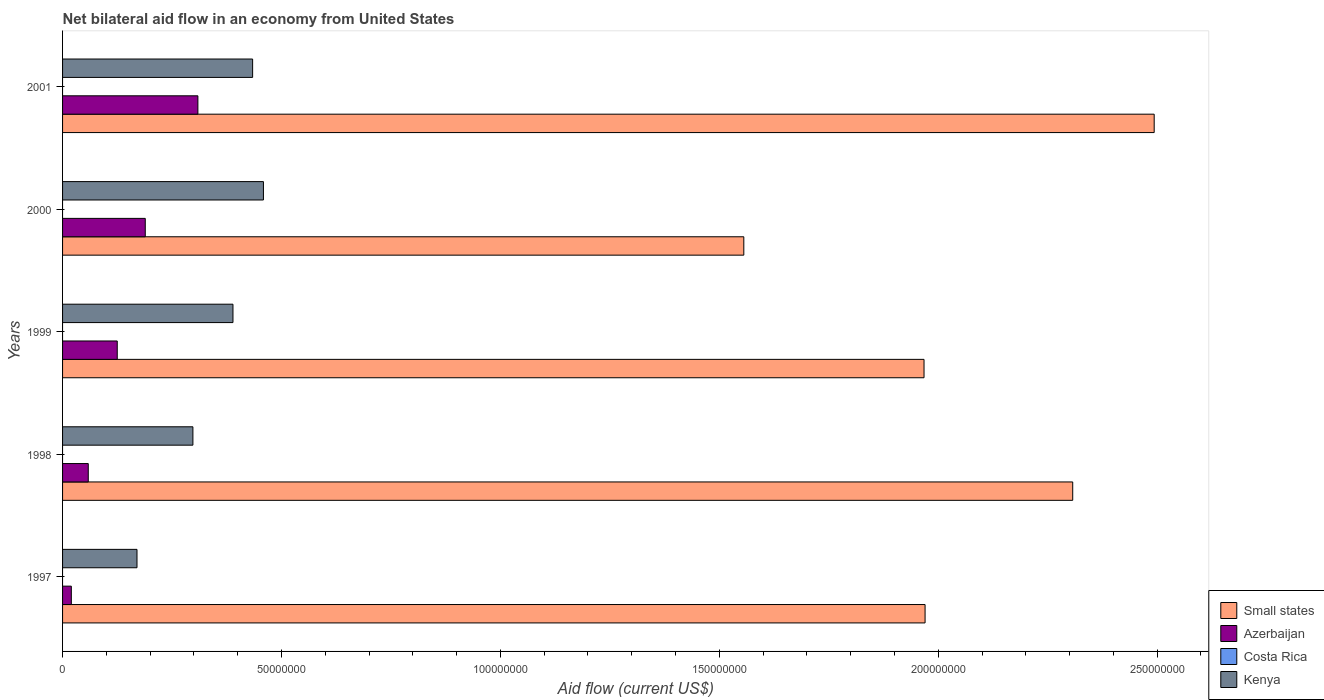How many different coloured bars are there?
Offer a terse response. 3. How many groups of bars are there?
Give a very brief answer. 5. How many bars are there on the 5th tick from the top?
Provide a succinct answer. 3. How many bars are there on the 1st tick from the bottom?
Offer a very short reply. 3. In how many cases, is the number of bars for a given year not equal to the number of legend labels?
Provide a succinct answer. 5. What is the net bilateral aid flow in Costa Rica in 1998?
Ensure brevity in your answer.  0. Across all years, what is the maximum net bilateral aid flow in Kenya?
Your answer should be very brief. 4.59e+07. Across all years, what is the minimum net bilateral aid flow in Costa Rica?
Offer a very short reply. 0. In which year was the net bilateral aid flow in Azerbaijan maximum?
Your response must be concise. 2001. What is the total net bilateral aid flow in Azerbaijan in the graph?
Provide a succinct answer. 7.02e+07. What is the difference between the net bilateral aid flow in Kenya in 2000 and that in 2001?
Provide a short and direct response. 2.47e+06. What is the difference between the net bilateral aid flow in Small states in 1997 and the net bilateral aid flow in Kenya in 2001?
Your response must be concise. 1.54e+08. What is the average net bilateral aid flow in Azerbaijan per year?
Your answer should be compact. 1.40e+07. In the year 2000, what is the difference between the net bilateral aid flow in Azerbaijan and net bilateral aid flow in Kenya?
Ensure brevity in your answer.  -2.70e+07. In how many years, is the net bilateral aid flow in Azerbaijan greater than 50000000 US$?
Your answer should be very brief. 0. What is the ratio of the net bilateral aid flow in Azerbaijan in 1997 to that in 1999?
Offer a very short reply. 0.16. Is the difference between the net bilateral aid flow in Azerbaijan in 1999 and 2001 greater than the difference between the net bilateral aid flow in Kenya in 1999 and 2001?
Provide a short and direct response. No. What is the difference between the highest and the second highest net bilateral aid flow in Azerbaijan?
Provide a short and direct response. 1.20e+07. What is the difference between the highest and the lowest net bilateral aid flow in Kenya?
Give a very brief answer. 2.89e+07. In how many years, is the net bilateral aid flow in Azerbaijan greater than the average net bilateral aid flow in Azerbaijan taken over all years?
Provide a short and direct response. 2. Is it the case that in every year, the sum of the net bilateral aid flow in Small states and net bilateral aid flow in Costa Rica is greater than the net bilateral aid flow in Azerbaijan?
Ensure brevity in your answer.  Yes. How many bars are there?
Your answer should be compact. 15. Are all the bars in the graph horizontal?
Offer a very short reply. Yes. How many years are there in the graph?
Make the answer very short. 5. What is the difference between two consecutive major ticks on the X-axis?
Provide a succinct answer. 5.00e+07. Does the graph contain grids?
Provide a short and direct response. No. How many legend labels are there?
Your answer should be compact. 4. How are the legend labels stacked?
Provide a short and direct response. Vertical. What is the title of the graph?
Provide a short and direct response. Net bilateral aid flow in an economy from United States. What is the label or title of the X-axis?
Your answer should be compact. Aid flow (current US$). What is the Aid flow (current US$) in Small states in 1997?
Make the answer very short. 1.97e+08. What is the Aid flow (current US$) of Kenya in 1997?
Your answer should be compact. 1.70e+07. What is the Aid flow (current US$) of Small states in 1998?
Provide a short and direct response. 2.31e+08. What is the Aid flow (current US$) in Azerbaijan in 1998?
Offer a terse response. 5.87e+06. What is the Aid flow (current US$) of Costa Rica in 1998?
Your response must be concise. 0. What is the Aid flow (current US$) of Kenya in 1998?
Offer a very short reply. 2.98e+07. What is the Aid flow (current US$) of Small states in 1999?
Provide a succinct answer. 1.97e+08. What is the Aid flow (current US$) of Azerbaijan in 1999?
Make the answer very short. 1.25e+07. What is the Aid flow (current US$) in Kenya in 1999?
Provide a short and direct response. 3.89e+07. What is the Aid flow (current US$) in Small states in 2000?
Your answer should be compact. 1.56e+08. What is the Aid flow (current US$) in Azerbaijan in 2000?
Give a very brief answer. 1.89e+07. What is the Aid flow (current US$) in Kenya in 2000?
Keep it short and to the point. 4.59e+07. What is the Aid flow (current US$) in Small states in 2001?
Your answer should be very brief. 2.49e+08. What is the Aid flow (current US$) of Azerbaijan in 2001?
Provide a succinct answer. 3.09e+07. What is the Aid flow (current US$) in Kenya in 2001?
Your answer should be compact. 4.34e+07. Across all years, what is the maximum Aid flow (current US$) of Small states?
Offer a very short reply. 2.49e+08. Across all years, what is the maximum Aid flow (current US$) of Azerbaijan?
Provide a succinct answer. 3.09e+07. Across all years, what is the maximum Aid flow (current US$) in Kenya?
Make the answer very short. 4.59e+07. Across all years, what is the minimum Aid flow (current US$) of Small states?
Your answer should be very brief. 1.56e+08. Across all years, what is the minimum Aid flow (current US$) in Kenya?
Your answer should be very brief. 1.70e+07. What is the total Aid flow (current US$) of Small states in the graph?
Provide a succinct answer. 1.03e+09. What is the total Aid flow (current US$) of Azerbaijan in the graph?
Your response must be concise. 7.02e+07. What is the total Aid flow (current US$) in Costa Rica in the graph?
Provide a succinct answer. 0. What is the total Aid flow (current US$) of Kenya in the graph?
Give a very brief answer. 1.75e+08. What is the difference between the Aid flow (current US$) of Small states in 1997 and that in 1998?
Give a very brief answer. -3.37e+07. What is the difference between the Aid flow (current US$) of Azerbaijan in 1997 and that in 1998?
Your response must be concise. -3.87e+06. What is the difference between the Aid flow (current US$) of Kenya in 1997 and that in 1998?
Provide a succinct answer. -1.28e+07. What is the difference between the Aid flow (current US$) in Small states in 1997 and that in 1999?
Keep it short and to the point. 2.40e+05. What is the difference between the Aid flow (current US$) of Azerbaijan in 1997 and that in 1999?
Provide a short and direct response. -1.05e+07. What is the difference between the Aid flow (current US$) in Kenya in 1997 and that in 1999?
Give a very brief answer. -2.19e+07. What is the difference between the Aid flow (current US$) of Small states in 1997 and that in 2000?
Your response must be concise. 4.14e+07. What is the difference between the Aid flow (current US$) of Azerbaijan in 1997 and that in 2000?
Offer a very short reply. -1.69e+07. What is the difference between the Aid flow (current US$) of Kenya in 1997 and that in 2000?
Make the answer very short. -2.89e+07. What is the difference between the Aid flow (current US$) in Small states in 1997 and that in 2001?
Offer a very short reply. -5.23e+07. What is the difference between the Aid flow (current US$) in Azerbaijan in 1997 and that in 2001?
Your answer should be very brief. -2.89e+07. What is the difference between the Aid flow (current US$) in Kenya in 1997 and that in 2001?
Make the answer very short. -2.64e+07. What is the difference between the Aid flow (current US$) of Small states in 1998 and that in 1999?
Ensure brevity in your answer.  3.40e+07. What is the difference between the Aid flow (current US$) in Azerbaijan in 1998 and that in 1999?
Offer a terse response. -6.62e+06. What is the difference between the Aid flow (current US$) of Kenya in 1998 and that in 1999?
Offer a very short reply. -9.15e+06. What is the difference between the Aid flow (current US$) of Small states in 1998 and that in 2000?
Your response must be concise. 7.51e+07. What is the difference between the Aid flow (current US$) in Azerbaijan in 1998 and that in 2000?
Your answer should be very brief. -1.30e+07. What is the difference between the Aid flow (current US$) of Kenya in 1998 and that in 2000?
Keep it short and to the point. -1.61e+07. What is the difference between the Aid flow (current US$) in Small states in 1998 and that in 2001?
Provide a succinct answer. -1.86e+07. What is the difference between the Aid flow (current US$) of Azerbaijan in 1998 and that in 2001?
Ensure brevity in your answer.  -2.50e+07. What is the difference between the Aid flow (current US$) of Kenya in 1998 and that in 2001?
Ensure brevity in your answer.  -1.36e+07. What is the difference between the Aid flow (current US$) of Small states in 1999 and that in 2000?
Offer a terse response. 4.12e+07. What is the difference between the Aid flow (current US$) of Azerbaijan in 1999 and that in 2000?
Ensure brevity in your answer.  -6.40e+06. What is the difference between the Aid flow (current US$) of Kenya in 1999 and that in 2000?
Ensure brevity in your answer.  -6.96e+06. What is the difference between the Aid flow (current US$) in Small states in 1999 and that in 2001?
Ensure brevity in your answer.  -5.26e+07. What is the difference between the Aid flow (current US$) in Azerbaijan in 1999 and that in 2001?
Make the answer very short. -1.84e+07. What is the difference between the Aid flow (current US$) in Kenya in 1999 and that in 2001?
Ensure brevity in your answer.  -4.49e+06. What is the difference between the Aid flow (current US$) of Small states in 2000 and that in 2001?
Give a very brief answer. -9.37e+07. What is the difference between the Aid flow (current US$) in Azerbaijan in 2000 and that in 2001?
Your answer should be compact. -1.20e+07. What is the difference between the Aid flow (current US$) in Kenya in 2000 and that in 2001?
Your response must be concise. 2.47e+06. What is the difference between the Aid flow (current US$) of Small states in 1997 and the Aid flow (current US$) of Azerbaijan in 1998?
Provide a succinct answer. 1.91e+08. What is the difference between the Aid flow (current US$) of Small states in 1997 and the Aid flow (current US$) of Kenya in 1998?
Your answer should be compact. 1.67e+08. What is the difference between the Aid flow (current US$) of Azerbaijan in 1997 and the Aid flow (current US$) of Kenya in 1998?
Offer a terse response. -2.78e+07. What is the difference between the Aid flow (current US$) of Small states in 1997 and the Aid flow (current US$) of Azerbaijan in 1999?
Provide a succinct answer. 1.85e+08. What is the difference between the Aid flow (current US$) in Small states in 1997 and the Aid flow (current US$) in Kenya in 1999?
Your answer should be very brief. 1.58e+08. What is the difference between the Aid flow (current US$) in Azerbaijan in 1997 and the Aid flow (current US$) in Kenya in 1999?
Your answer should be compact. -3.69e+07. What is the difference between the Aid flow (current US$) in Small states in 1997 and the Aid flow (current US$) in Azerbaijan in 2000?
Your answer should be compact. 1.78e+08. What is the difference between the Aid flow (current US$) in Small states in 1997 and the Aid flow (current US$) in Kenya in 2000?
Offer a terse response. 1.51e+08. What is the difference between the Aid flow (current US$) in Azerbaijan in 1997 and the Aid flow (current US$) in Kenya in 2000?
Your answer should be very brief. -4.39e+07. What is the difference between the Aid flow (current US$) in Small states in 1997 and the Aid flow (current US$) in Azerbaijan in 2001?
Your response must be concise. 1.66e+08. What is the difference between the Aid flow (current US$) in Small states in 1997 and the Aid flow (current US$) in Kenya in 2001?
Give a very brief answer. 1.54e+08. What is the difference between the Aid flow (current US$) of Azerbaijan in 1997 and the Aid flow (current US$) of Kenya in 2001?
Give a very brief answer. -4.14e+07. What is the difference between the Aid flow (current US$) in Small states in 1998 and the Aid flow (current US$) in Azerbaijan in 1999?
Ensure brevity in your answer.  2.18e+08. What is the difference between the Aid flow (current US$) of Small states in 1998 and the Aid flow (current US$) of Kenya in 1999?
Provide a succinct answer. 1.92e+08. What is the difference between the Aid flow (current US$) of Azerbaijan in 1998 and the Aid flow (current US$) of Kenya in 1999?
Provide a succinct answer. -3.30e+07. What is the difference between the Aid flow (current US$) in Small states in 1998 and the Aid flow (current US$) in Azerbaijan in 2000?
Offer a terse response. 2.12e+08. What is the difference between the Aid flow (current US$) of Small states in 1998 and the Aid flow (current US$) of Kenya in 2000?
Provide a succinct answer. 1.85e+08. What is the difference between the Aid flow (current US$) in Azerbaijan in 1998 and the Aid flow (current US$) in Kenya in 2000?
Provide a short and direct response. -4.00e+07. What is the difference between the Aid flow (current US$) in Small states in 1998 and the Aid flow (current US$) in Azerbaijan in 2001?
Offer a terse response. 2.00e+08. What is the difference between the Aid flow (current US$) in Small states in 1998 and the Aid flow (current US$) in Kenya in 2001?
Provide a succinct answer. 1.87e+08. What is the difference between the Aid flow (current US$) of Azerbaijan in 1998 and the Aid flow (current US$) of Kenya in 2001?
Your response must be concise. -3.75e+07. What is the difference between the Aid flow (current US$) of Small states in 1999 and the Aid flow (current US$) of Azerbaijan in 2000?
Make the answer very short. 1.78e+08. What is the difference between the Aid flow (current US$) of Small states in 1999 and the Aid flow (current US$) of Kenya in 2000?
Make the answer very short. 1.51e+08. What is the difference between the Aid flow (current US$) in Azerbaijan in 1999 and the Aid flow (current US$) in Kenya in 2000?
Offer a very short reply. -3.34e+07. What is the difference between the Aid flow (current US$) in Small states in 1999 and the Aid flow (current US$) in Azerbaijan in 2001?
Provide a succinct answer. 1.66e+08. What is the difference between the Aid flow (current US$) in Small states in 1999 and the Aid flow (current US$) in Kenya in 2001?
Provide a short and direct response. 1.53e+08. What is the difference between the Aid flow (current US$) of Azerbaijan in 1999 and the Aid flow (current US$) of Kenya in 2001?
Make the answer very short. -3.09e+07. What is the difference between the Aid flow (current US$) of Small states in 2000 and the Aid flow (current US$) of Azerbaijan in 2001?
Ensure brevity in your answer.  1.25e+08. What is the difference between the Aid flow (current US$) of Small states in 2000 and the Aid flow (current US$) of Kenya in 2001?
Offer a very short reply. 1.12e+08. What is the difference between the Aid flow (current US$) of Azerbaijan in 2000 and the Aid flow (current US$) of Kenya in 2001?
Ensure brevity in your answer.  -2.45e+07. What is the average Aid flow (current US$) in Small states per year?
Offer a very short reply. 2.06e+08. What is the average Aid flow (current US$) in Azerbaijan per year?
Make the answer very short. 1.40e+07. What is the average Aid flow (current US$) in Costa Rica per year?
Provide a short and direct response. 0. What is the average Aid flow (current US$) of Kenya per year?
Keep it short and to the point. 3.50e+07. In the year 1997, what is the difference between the Aid flow (current US$) in Small states and Aid flow (current US$) in Azerbaijan?
Your response must be concise. 1.95e+08. In the year 1997, what is the difference between the Aid flow (current US$) of Small states and Aid flow (current US$) of Kenya?
Your response must be concise. 1.80e+08. In the year 1997, what is the difference between the Aid flow (current US$) of Azerbaijan and Aid flow (current US$) of Kenya?
Provide a succinct answer. -1.50e+07. In the year 1998, what is the difference between the Aid flow (current US$) in Small states and Aid flow (current US$) in Azerbaijan?
Give a very brief answer. 2.25e+08. In the year 1998, what is the difference between the Aid flow (current US$) of Small states and Aid flow (current US$) of Kenya?
Provide a succinct answer. 2.01e+08. In the year 1998, what is the difference between the Aid flow (current US$) in Azerbaijan and Aid flow (current US$) in Kenya?
Ensure brevity in your answer.  -2.39e+07. In the year 1999, what is the difference between the Aid flow (current US$) in Small states and Aid flow (current US$) in Azerbaijan?
Provide a short and direct response. 1.84e+08. In the year 1999, what is the difference between the Aid flow (current US$) of Small states and Aid flow (current US$) of Kenya?
Provide a succinct answer. 1.58e+08. In the year 1999, what is the difference between the Aid flow (current US$) of Azerbaijan and Aid flow (current US$) of Kenya?
Provide a succinct answer. -2.64e+07. In the year 2000, what is the difference between the Aid flow (current US$) in Small states and Aid flow (current US$) in Azerbaijan?
Your answer should be very brief. 1.37e+08. In the year 2000, what is the difference between the Aid flow (current US$) of Small states and Aid flow (current US$) of Kenya?
Make the answer very short. 1.10e+08. In the year 2000, what is the difference between the Aid flow (current US$) of Azerbaijan and Aid flow (current US$) of Kenya?
Your response must be concise. -2.70e+07. In the year 2001, what is the difference between the Aid flow (current US$) in Small states and Aid flow (current US$) in Azerbaijan?
Give a very brief answer. 2.18e+08. In the year 2001, what is the difference between the Aid flow (current US$) in Small states and Aid flow (current US$) in Kenya?
Your response must be concise. 2.06e+08. In the year 2001, what is the difference between the Aid flow (current US$) in Azerbaijan and Aid flow (current US$) in Kenya?
Offer a very short reply. -1.25e+07. What is the ratio of the Aid flow (current US$) in Small states in 1997 to that in 1998?
Make the answer very short. 0.85. What is the ratio of the Aid flow (current US$) in Azerbaijan in 1997 to that in 1998?
Offer a terse response. 0.34. What is the ratio of the Aid flow (current US$) in Kenya in 1997 to that in 1998?
Give a very brief answer. 0.57. What is the ratio of the Aid flow (current US$) in Azerbaijan in 1997 to that in 1999?
Offer a terse response. 0.16. What is the ratio of the Aid flow (current US$) of Kenya in 1997 to that in 1999?
Your response must be concise. 0.44. What is the ratio of the Aid flow (current US$) in Small states in 1997 to that in 2000?
Your answer should be compact. 1.27. What is the ratio of the Aid flow (current US$) in Azerbaijan in 1997 to that in 2000?
Give a very brief answer. 0.11. What is the ratio of the Aid flow (current US$) of Kenya in 1997 to that in 2000?
Your answer should be compact. 0.37. What is the ratio of the Aid flow (current US$) of Small states in 1997 to that in 2001?
Give a very brief answer. 0.79. What is the ratio of the Aid flow (current US$) of Azerbaijan in 1997 to that in 2001?
Keep it short and to the point. 0.06. What is the ratio of the Aid flow (current US$) of Kenya in 1997 to that in 2001?
Your answer should be very brief. 0.39. What is the ratio of the Aid flow (current US$) in Small states in 1998 to that in 1999?
Keep it short and to the point. 1.17. What is the ratio of the Aid flow (current US$) of Azerbaijan in 1998 to that in 1999?
Provide a succinct answer. 0.47. What is the ratio of the Aid flow (current US$) in Kenya in 1998 to that in 1999?
Give a very brief answer. 0.76. What is the ratio of the Aid flow (current US$) in Small states in 1998 to that in 2000?
Your answer should be compact. 1.48. What is the ratio of the Aid flow (current US$) in Azerbaijan in 1998 to that in 2000?
Your response must be concise. 0.31. What is the ratio of the Aid flow (current US$) of Kenya in 1998 to that in 2000?
Your response must be concise. 0.65. What is the ratio of the Aid flow (current US$) in Small states in 1998 to that in 2001?
Give a very brief answer. 0.93. What is the ratio of the Aid flow (current US$) in Azerbaijan in 1998 to that in 2001?
Ensure brevity in your answer.  0.19. What is the ratio of the Aid flow (current US$) in Kenya in 1998 to that in 2001?
Your answer should be compact. 0.69. What is the ratio of the Aid flow (current US$) in Small states in 1999 to that in 2000?
Your answer should be compact. 1.26. What is the ratio of the Aid flow (current US$) in Azerbaijan in 1999 to that in 2000?
Your answer should be compact. 0.66. What is the ratio of the Aid flow (current US$) in Kenya in 1999 to that in 2000?
Offer a terse response. 0.85. What is the ratio of the Aid flow (current US$) in Small states in 1999 to that in 2001?
Provide a short and direct response. 0.79. What is the ratio of the Aid flow (current US$) of Azerbaijan in 1999 to that in 2001?
Provide a succinct answer. 0.4. What is the ratio of the Aid flow (current US$) of Kenya in 1999 to that in 2001?
Offer a very short reply. 0.9. What is the ratio of the Aid flow (current US$) in Small states in 2000 to that in 2001?
Keep it short and to the point. 0.62. What is the ratio of the Aid flow (current US$) of Azerbaijan in 2000 to that in 2001?
Provide a succinct answer. 0.61. What is the ratio of the Aid flow (current US$) of Kenya in 2000 to that in 2001?
Provide a succinct answer. 1.06. What is the difference between the highest and the second highest Aid flow (current US$) in Small states?
Provide a short and direct response. 1.86e+07. What is the difference between the highest and the second highest Aid flow (current US$) of Azerbaijan?
Ensure brevity in your answer.  1.20e+07. What is the difference between the highest and the second highest Aid flow (current US$) in Kenya?
Provide a short and direct response. 2.47e+06. What is the difference between the highest and the lowest Aid flow (current US$) in Small states?
Provide a short and direct response. 9.37e+07. What is the difference between the highest and the lowest Aid flow (current US$) in Azerbaijan?
Make the answer very short. 2.89e+07. What is the difference between the highest and the lowest Aid flow (current US$) of Kenya?
Offer a terse response. 2.89e+07. 